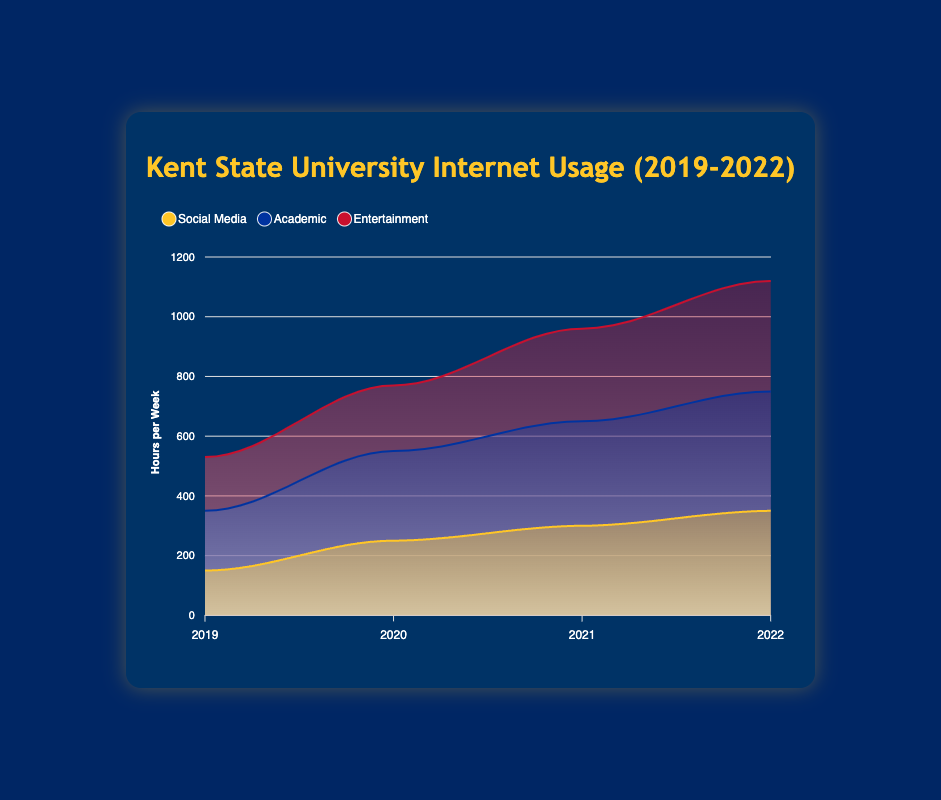What is the title of the chart? The title of the chart is displayed at the top of the figure.
Answer: Kent State University Internet Usage (2019-2022) What are the three categories shown in the chart? The chart breaks down internet usage into three categories, which are visible in the legend at the top.
Answer: Social Media, Academic, Entertainment How many years are displayed on the x-axis? Count the number of tick marks or labels on the x-axis.
Answer: 4 Which category has the highest internet usage in 2022? Look at the height of the areas at the point corresponding to 2022 and identify the tallest one.
Answer: Academic What is the trend in Social Media usage from 2019 to 2022? Follow the area of the Social Media category from 2019 to 2022 and describe if it increases, decreases, or remains constant.
Answer: Increases How much did Academic usage increase from 2019 to 2022? Subtract the Academic usage in 2019 from the Academic usage in 2022.
Answer: 200 hours What is the total internet usage for all categories combined in 2021? Add the values for Social Media, Academic, and Entertainment for the year 2021.
Answer: 960 hours Which year saw the highest increase in Entertainment usage compared to the previous year? Compare the difference in Entertainment usage between consecutive years and identify the year with the largest increase.
Answer: 2020-2021 How does the trend in Academic usage compare to the trend in Entertainment usage from 2019 to 2022? Describe the patterns of increase or decrease for both Academic and Entertainment categories over the years.
Answer: Both categories show an increasing trend What does the smooth curve in the chart indicate about the data? Area charts with smooth curves indicate gradual changes rather than abrupt shifts in the data values.
Answer: Gradual changes in internet usage 